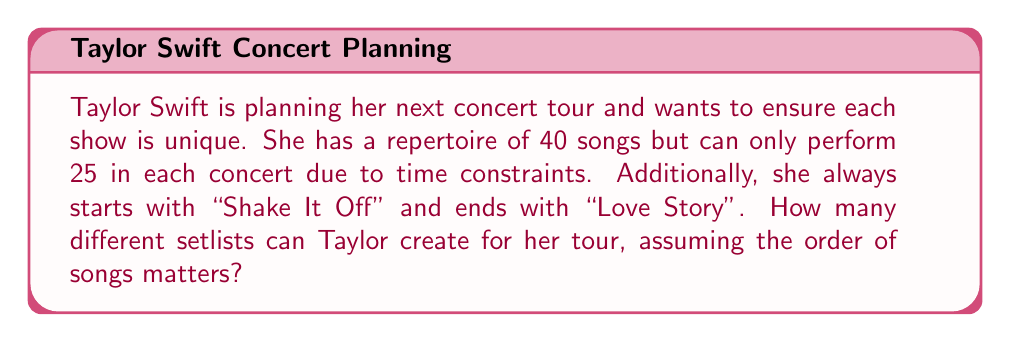Solve this math problem. Let's approach this step-by-step:

1) We start with 40 songs in total, but two positions are fixed:
   - "Shake It Off" always starts the show
   - "Love Story" always ends the show

2) This means we need to arrange 23 songs out of the remaining 38 songs (40 - 2 fixed songs) for the middle portion of the setlist.

3) This is a permutation problem. We're selecting 23 songs out of 38 and the order matters.

4) The formula for permutations is:

   $$P(n,r) = \frac{n!}{(n-r)!}$$

   Where $n$ is the total number of items to choose from, and $r$ is the number of items being chosen.

5) In this case, $n = 38$ and $r = 23$

6) Plugging these values into our formula:

   $$P(38,23) = \frac{38!}{(38-23)!} = \frac{38!}{15!}$$

7) Calculating this out:
   
   $$\frac{38!}{15!} = 38 \times 37 \times 36 \times ... \times 17 \times 16$$

8) This equals approximately $1.5484 \times 10^{32}$

Therefore, Taylor Swift can create about $1.5484 \times 10^{32}$ unique setlists for her tour.
Answer: $1.5484 \times 10^{32}$ unique setlists 